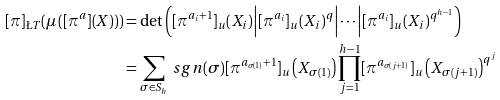<formula> <loc_0><loc_0><loc_500><loc_500>[ \pi ] _ { \L T } ( \mu \left ( [ \pi ^ { a } ] ( X ) \right ) ) & = \det \left ( [ \pi ^ { a _ { i } + 1 } ] _ { u } ( X _ { i } ) \Big | [ \pi ^ { a _ { i } } ] _ { u } ( X _ { i } ) ^ { q } \Big | \cdots \Big | [ \pi ^ { a _ { i } } ] _ { u } ( X _ { i } ) ^ { q ^ { h - 1 } } \right ) \\ & = \sum _ { \sigma \in S _ { h } } \ s g n ( \sigma ) [ \pi ^ { a _ { \sigma ( 1 ) } + 1 } ] _ { u } \left ( X _ { \sigma ( 1 ) } \right ) \prod _ { j = 1 } ^ { h - 1 } [ \pi ^ { a _ { \sigma ( j + 1 ) } } ] _ { u } \left ( X _ { \sigma ( j + 1 ) } \right ) ^ { q ^ { j } }</formula> 